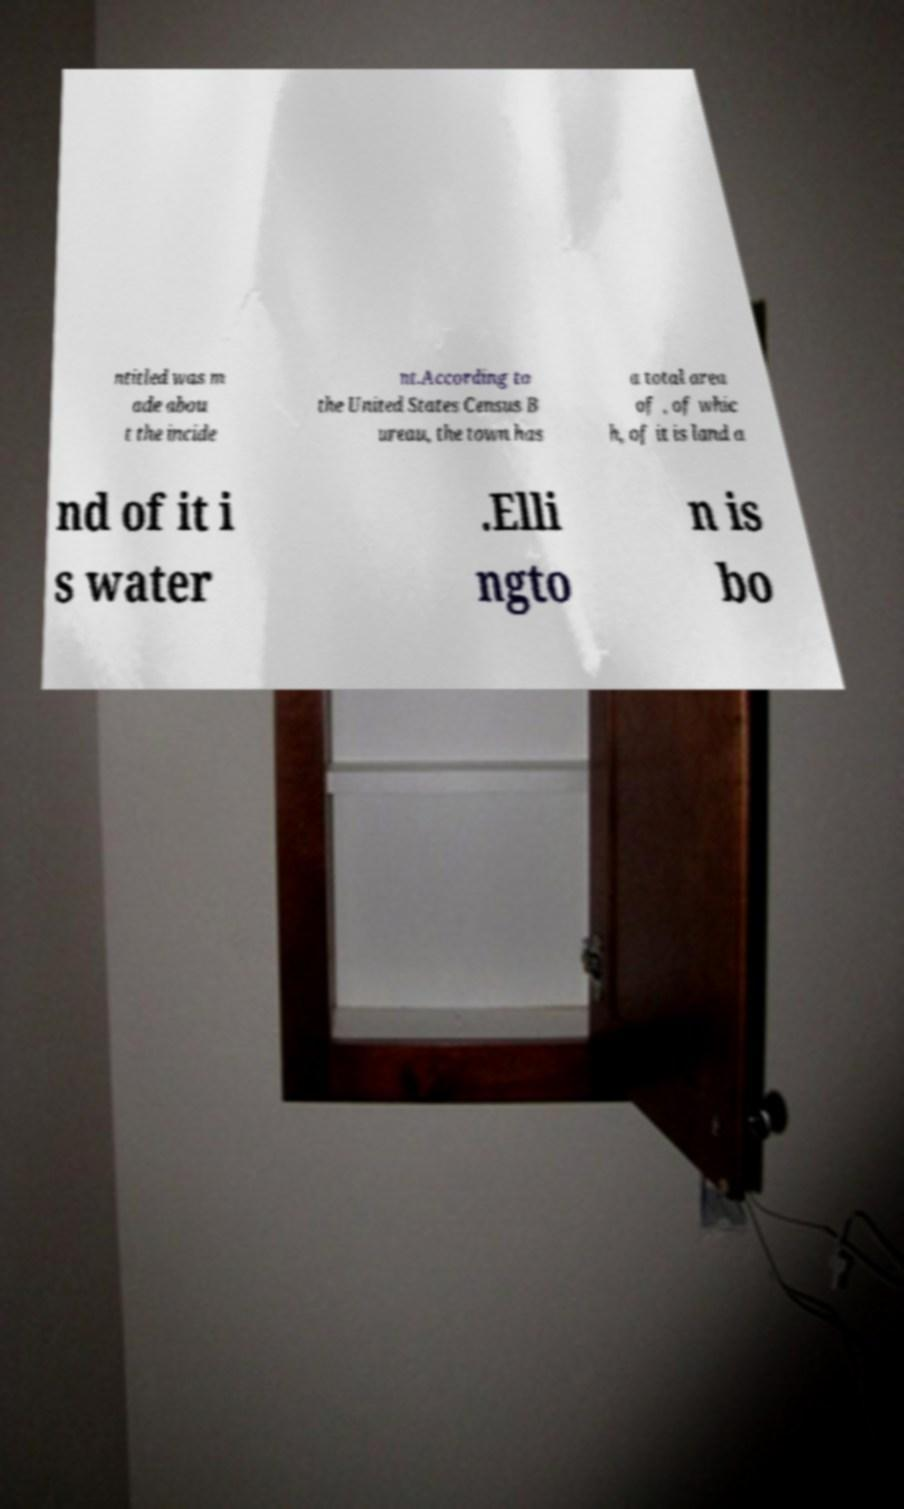Could you assist in decoding the text presented in this image and type it out clearly? ntitled was m ade abou t the incide nt.According to the United States Census B ureau, the town has a total area of , of whic h, of it is land a nd of it i s water .Elli ngto n is bo 